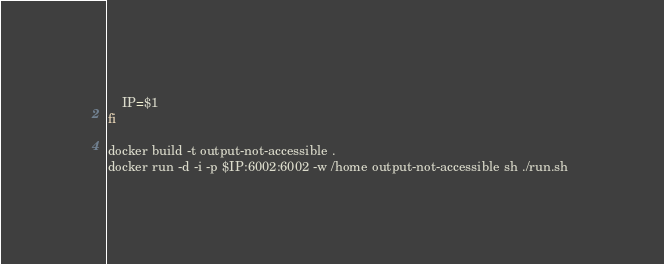<code> <loc_0><loc_0><loc_500><loc_500><_Bash_>    IP=$1
fi

docker build -t output-not-accessible .
docker run -d -i -p $IP:6002:6002 -w /home output-not-accessible sh ./run.sh </code> 